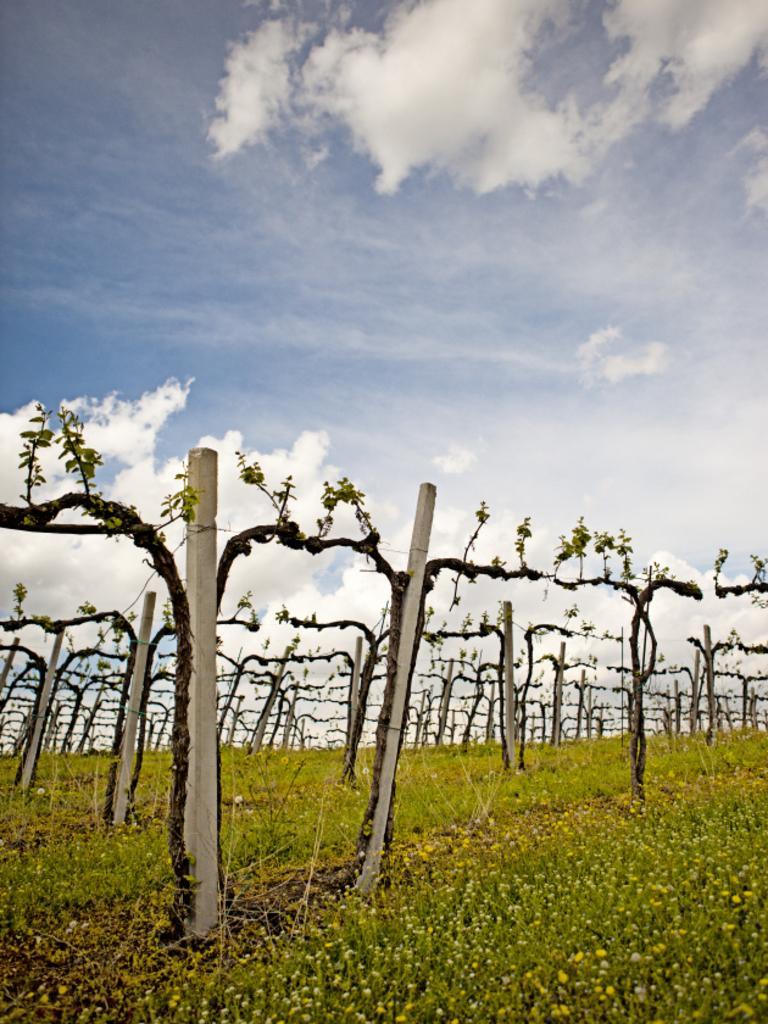Describe this image in one or two sentences. In this image we can see group of plants, poles. In the foreground we can see the grass. In the background, we can see the cloudy sky. 